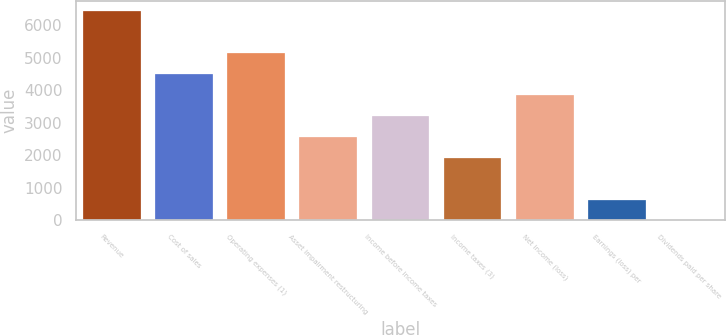Convert chart to OTSL. <chart><loc_0><loc_0><loc_500><loc_500><bar_chart><fcel>Revenue<fcel>Cost of sales<fcel>Operating expenses (1)<fcel>Asset impairment restructuring<fcel>Income before income taxes<fcel>Income taxes (3)<fcel>Net income (loss)<fcel>Earnings (loss) per<fcel>Dividends paid per share<nl><fcel>6438.6<fcel>4507.16<fcel>5150.96<fcel>2575.76<fcel>3219.56<fcel>1931.96<fcel>3863.36<fcel>644.36<fcel>0.56<nl></chart> 